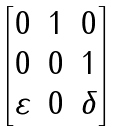<formula> <loc_0><loc_0><loc_500><loc_500>\begin{bmatrix} 0 & 1 & 0 \\ 0 & 0 & 1 \\ \varepsilon & 0 & \delta \end{bmatrix}</formula> 